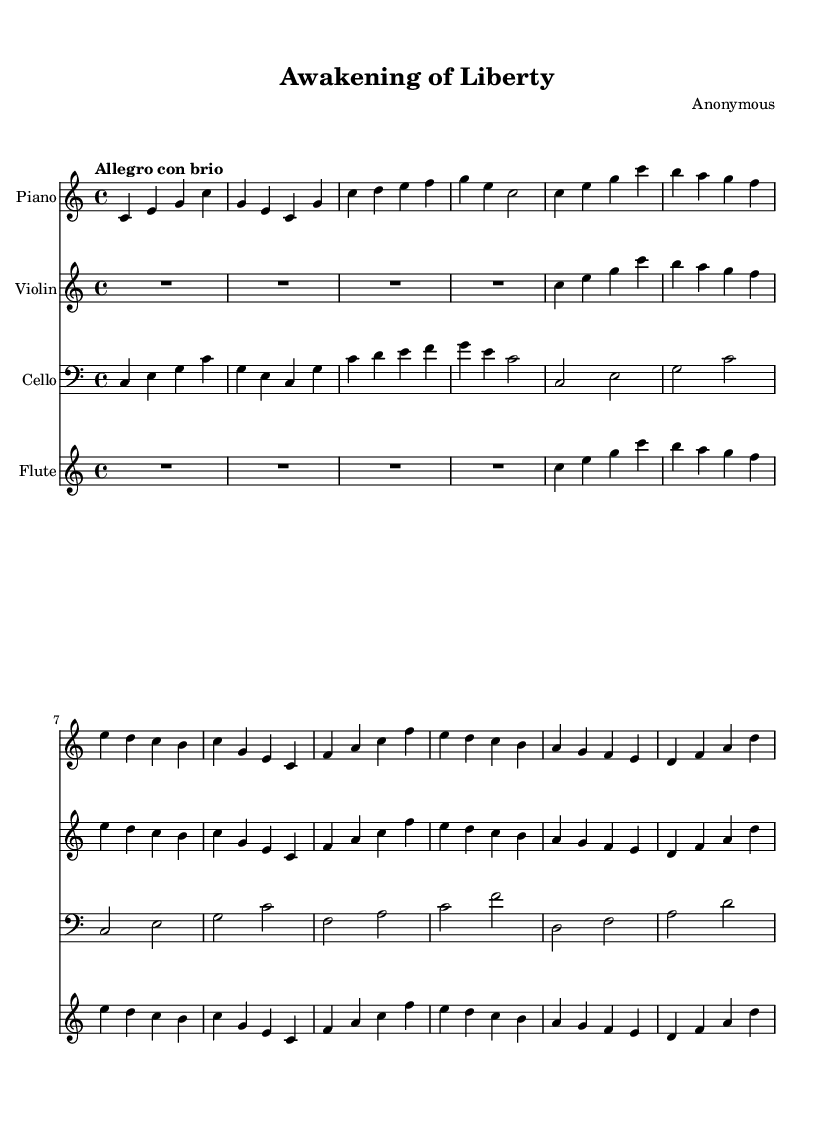What is the key signature of this music? The key signature is indicated at the beginning of the staff and shows no sharps or flats, which indicates that it is in C major.
Answer: C major What is the time signature of this composition? The time signature is shown at the beginning of the score and is 4/4, meaning there are four beats in each measure.
Answer: 4/4 What is the tempo marking of the piece? The tempo marking appears at the beginning and states "Allegro con brio," indicating a lively and brisk pace.
Answer: Allegro con brio How many measures are in Theme A? By counting the measures in the section labeled Theme A, we find there are four distinct measures.
Answer: Four In which section does the flute first play? The flute first plays in the second measure of the introduction, as indicated by the notation starting at that point.
Answer: Introduction What instruments are included in this composition? The instruments are listed at the beginning of each staff, and they are Piano, Violin, Cello, and Flute.
Answer: Piano, Violin, Cello, Flute How does Theme B differ from Theme A in terms of melody? By comparing the notes in both themes, it's clear that Theme B introduces a new melody that does not repeat Theme A, providing a contrast in musical ideas.
Answer: New melody 